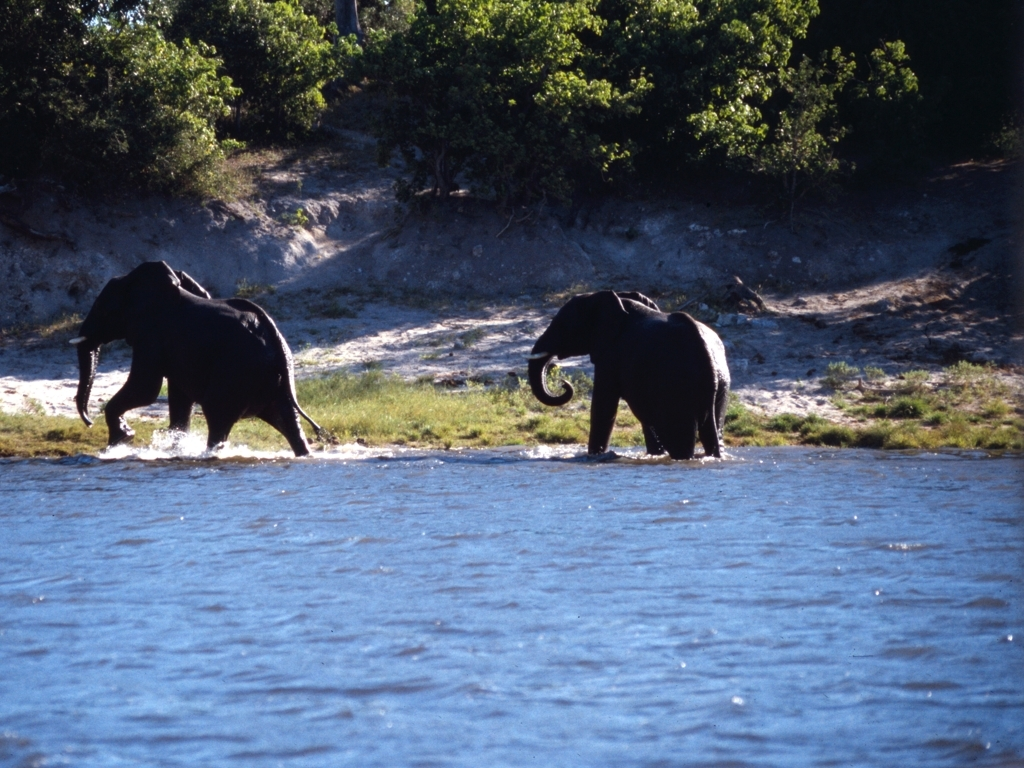What time of day does this scene likely depict? The long shadows and warm lighting suggest this scene is likely capturing the golden hours of early morning or late afternoon when the sun is close to the horizon. 